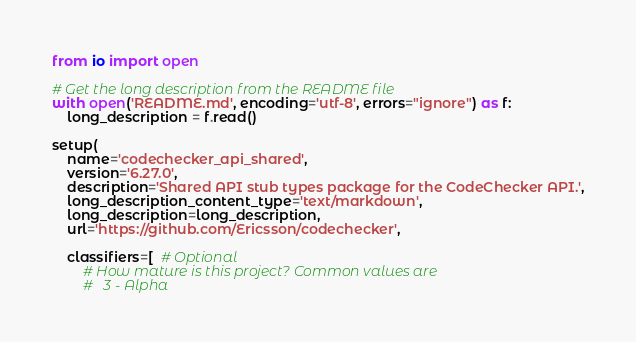<code> <loc_0><loc_0><loc_500><loc_500><_Python_>from io import open

# Get the long description from the README file
with open('README.md', encoding='utf-8', errors="ignore") as f:
    long_description = f.read()

setup(
    name='codechecker_api_shared',
    version='6.27.0',
    description='Shared API stub types package for the CodeChecker API.',
    long_description_content_type='text/markdown',
    long_description=long_description,
    url='https://github.com/Ericsson/codechecker',

    classifiers=[  # Optional
        # How mature is this project? Common values are
        #   3 - Alpha</code> 